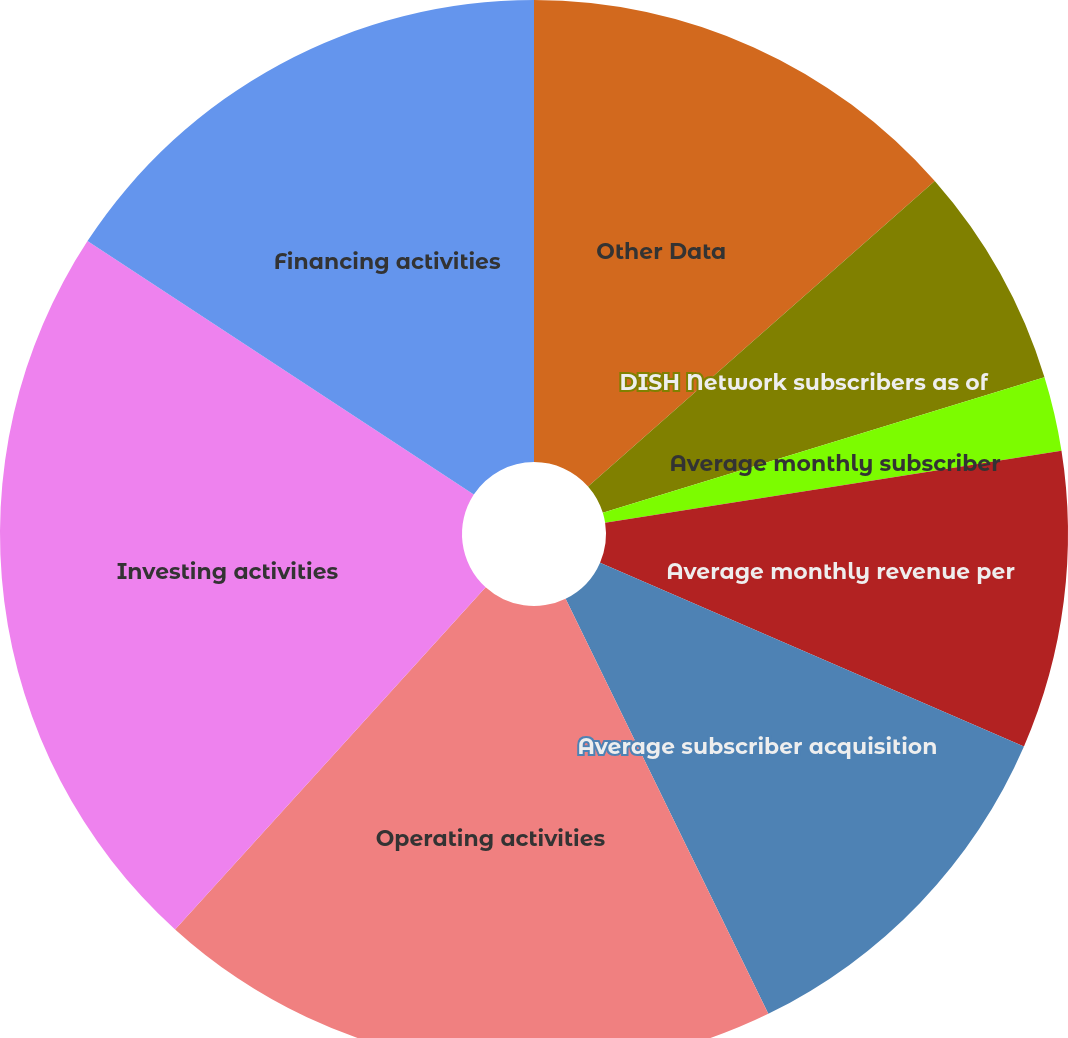Convert chart to OTSL. <chart><loc_0><loc_0><loc_500><loc_500><pie_chart><fcel>Other Data<fcel>DISH Network subscribers as of<fcel>DISH Network subscriber<fcel>Average monthly subscriber<fcel>Average monthly revenue per<fcel>Average subscriber acquisition<fcel>Operating activities<fcel>Investing activities<fcel>Financing activities<nl><fcel>13.51%<fcel>6.75%<fcel>0.0%<fcel>2.25%<fcel>9.0%<fcel>11.26%<fcel>18.96%<fcel>22.51%<fcel>15.76%<nl></chart> 